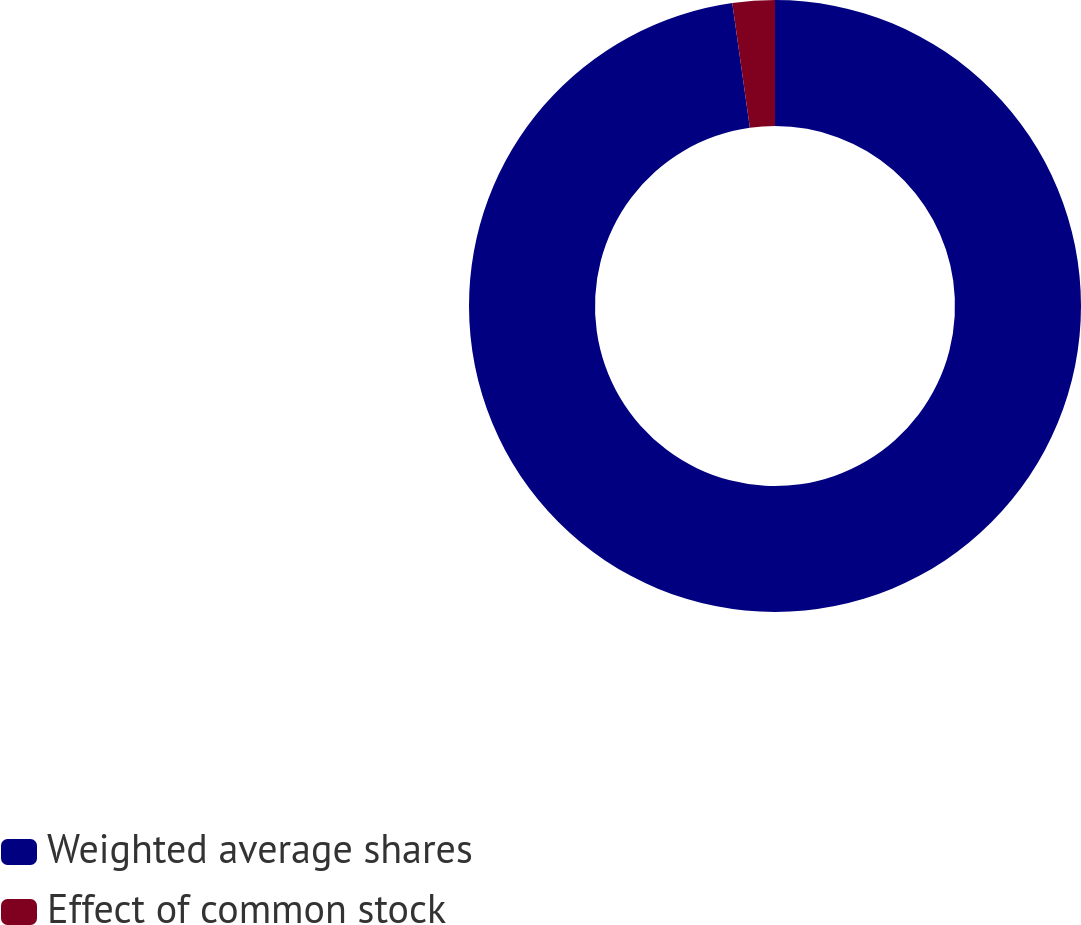Convert chart. <chart><loc_0><loc_0><loc_500><loc_500><pie_chart><fcel>Weighted average shares<fcel>Effect of common stock<nl><fcel>97.77%<fcel>2.23%<nl></chart> 